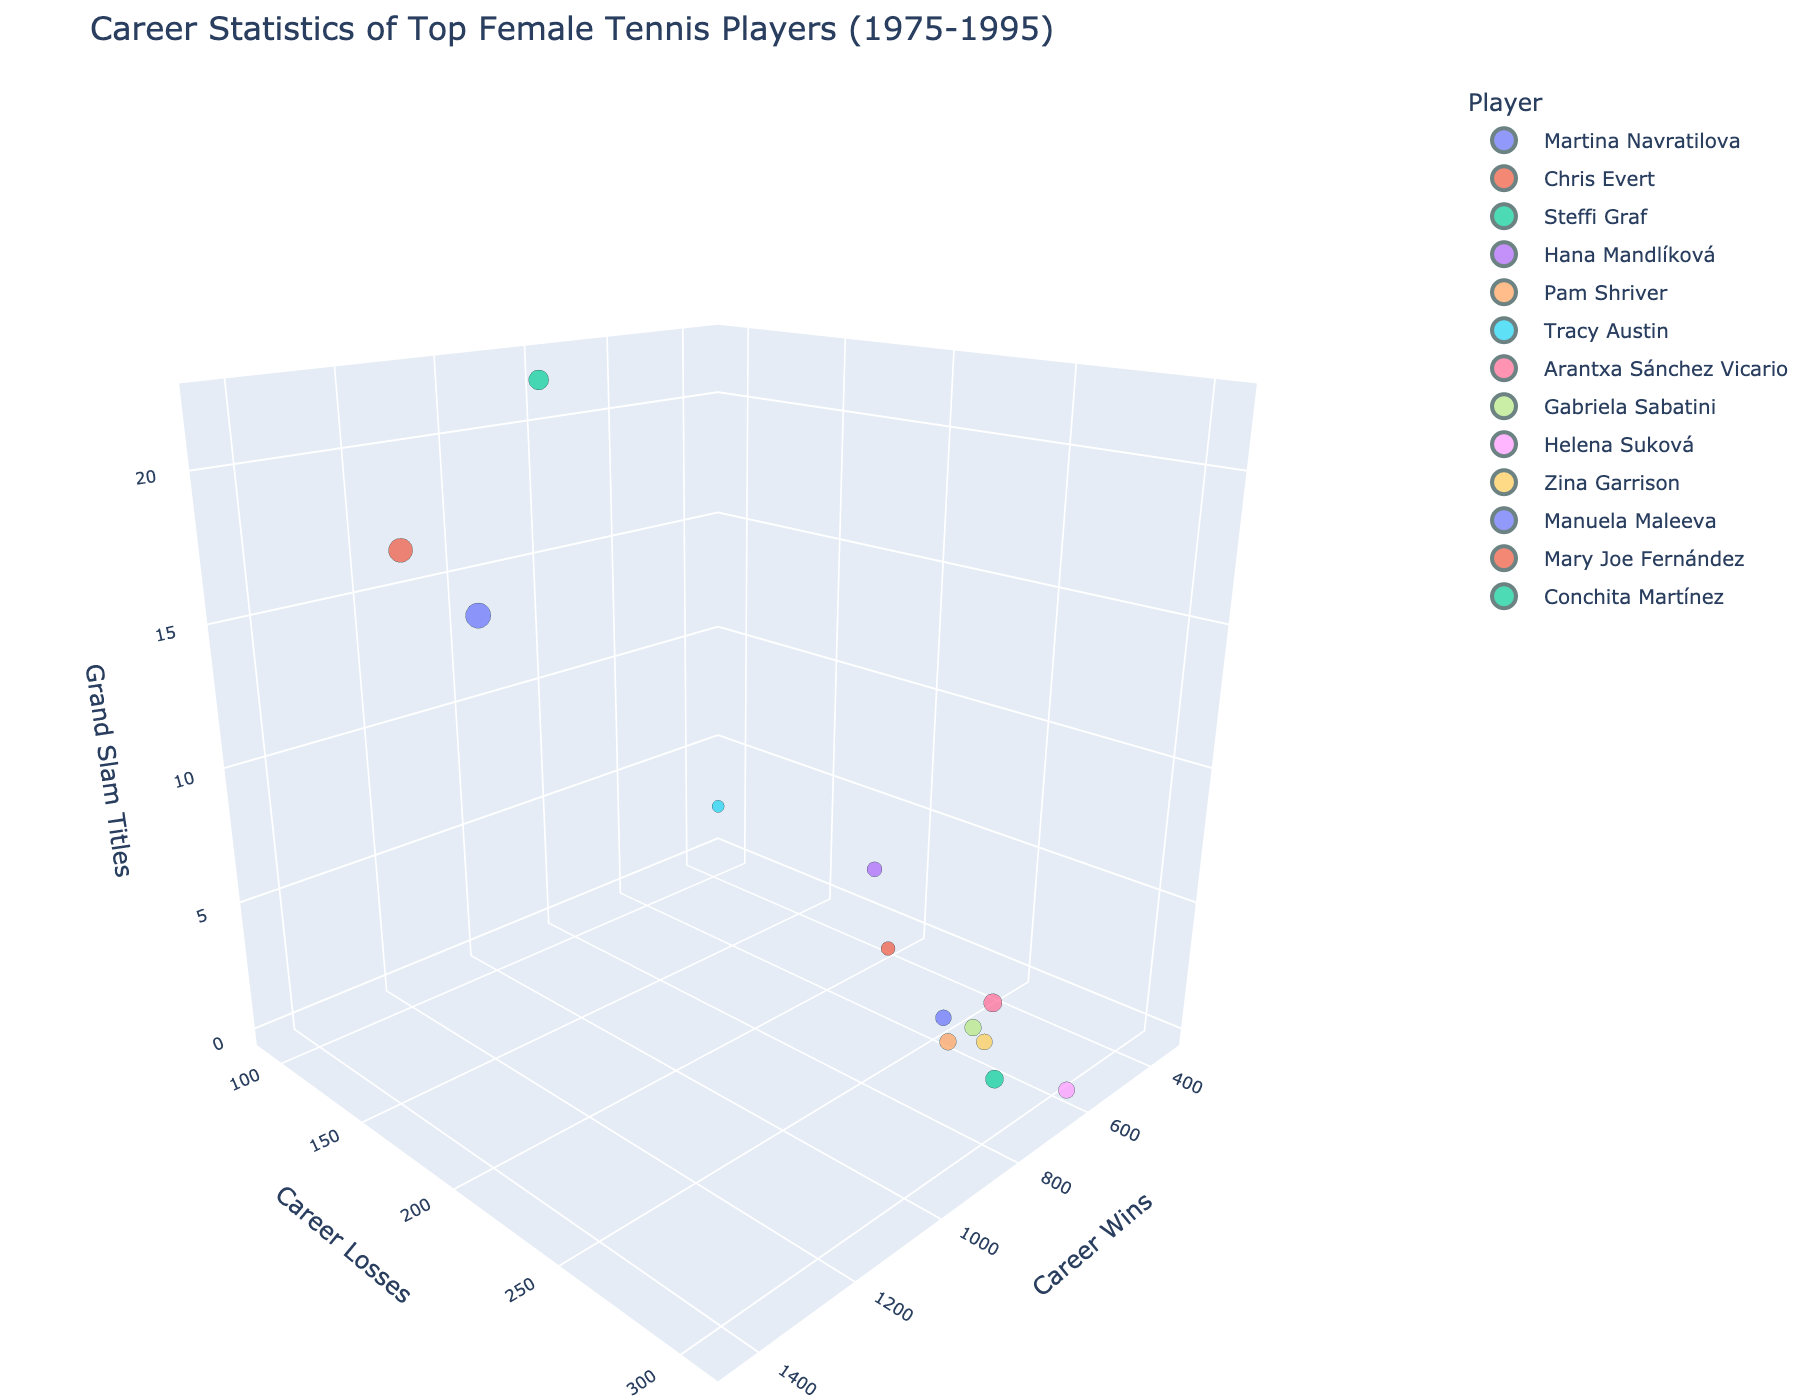What is the title of the plot? The title is displayed at the top of the figure, usually in large font. It's meant to provide a summary of what the plot is about.
Answer: Career Statistics of Top Female Tennis Players (1975-1995) Which player has the highest number of career wins? To find the player with the highest wins, look at the scale on the wins axis and identify the player associated with the highest value.
Answer: Martina Navratilova How many players have won 0 Grand Slam titles? Check the points lying on the plane where the Grand Slam Titles (z-axis) are zero and count them.
Answer: 5 Compare the career losses of Steffi Graf and Gabriela Sabatini. Who has more losses? Find and compare the positions of Steffi Graf and Gabriela Sabatini on the losses axis (y-axis). Steffi Graf has fewer losses (115) compared to Gabriela Sabatini (271).
Answer: Gabriela Sabatini What is the average number of Grand Slam titles among the players? Sum the Grand Slam titles for all players and then divide by the number of players (18+18+22+4+0+2+4+1+0+0+0+0+1 = 70; 70/13 ≈ 5.38).
Answer: 5.38 Who has a worse win-loss record: Arantxa Sánchez Vicario or Manuela Maleeva? Calculate the win-loss difference for both players. Arantxa Sánchez Vicario: 759-295 = 464. Manuela Maleeva: 572-250 = 322. The player with the lower difference has a worse record.
Answer: Manuela Maleeva What is the total number of career wins for all players combined? Sum the total wins for all players (1442+1309+900+508+632+335+759+632+614+587+572+437+739 = 9466).
Answer: 9466 Which player has the highest number of Grand Slam titles and how many? Find the player who is at the highest value of the Grand Slam Titles axis (z-axis). Steffi Graf has the highest number with 22 titles.
Answer: Steffi Graf, 22 Who has a better win-loss ratio: Tracy Austin or Mary Joe Fernández? Calculate the win-loss ratio for both players. Tracy Austin: 335/90 ≈ 3.72. Mary Joe Fernández: 437/203 ≈ 2.15. The higher ratio indicates a better win-loss record.
Answer: Tracy Austin Which players have more than 600 career wins? Identify the points above the 600 mark on the wins axis, then find the corresponding players.
Answer: Martina Navratilova, Chris Evert, Steffi Graf, Pam Shriver, Arantxa Sánchez Vicario, Gabriela Sabatini, Helena Suková 